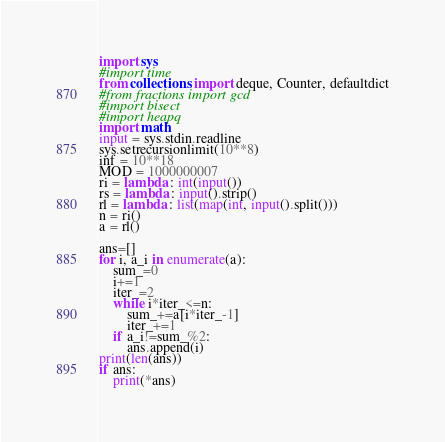Convert code to text. <code><loc_0><loc_0><loc_500><loc_500><_Python_>import sys
#import time
from collections import deque, Counter, defaultdict
#from fractions import gcd
#import bisect
#import heapq
import math
input = sys.stdin.readline
sys.setrecursionlimit(10**8)
inf = 10**18
MOD = 1000000007
ri = lambda : int(input())
rs = lambda : input().strip()
rl = lambda : list(map(int, input().split()))
n = ri()
a = rl()

ans=[]
for i, a_i in enumerate(a):
    sum_=0
    i+=1
    iter_=2
    while i*iter_<=n:
        sum_+=a[i*iter_-1]
        iter_+=1
    if a_i!=sum_%2:
        ans.append(i)
print(len(ans))
if ans:
    print(*ans)</code> 